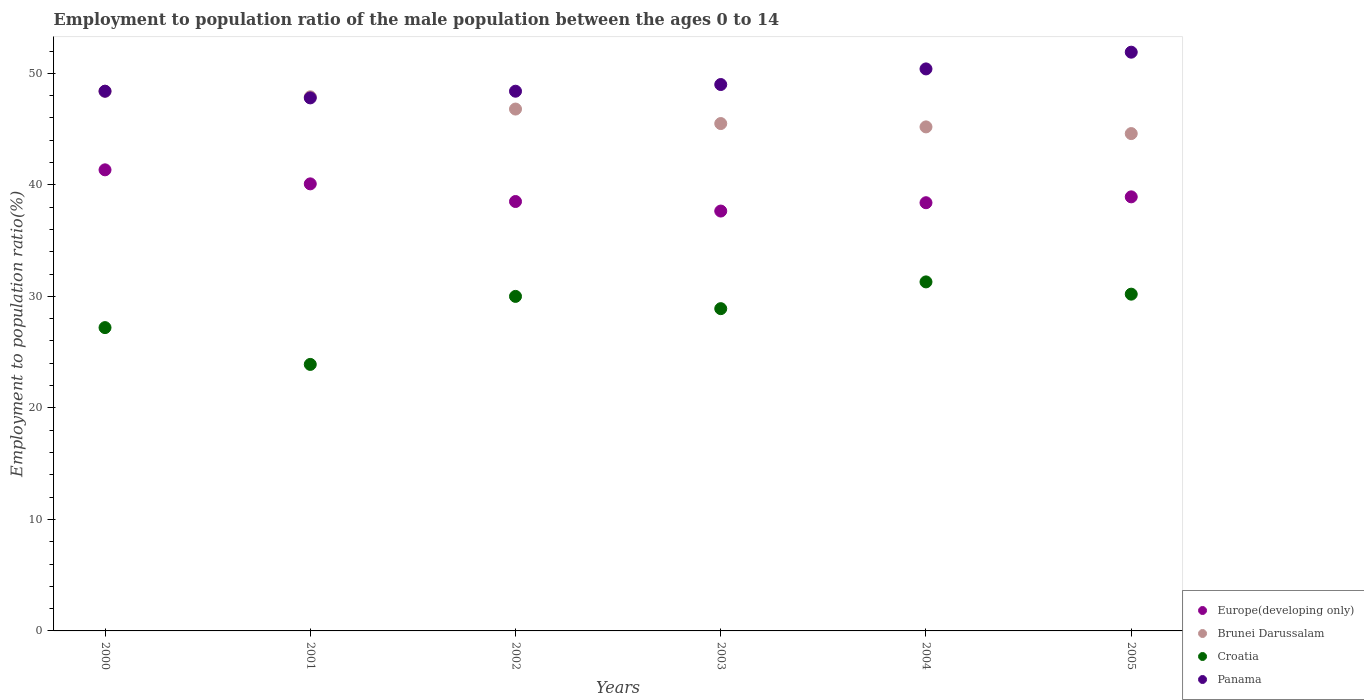How many different coloured dotlines are there?
Your response must be concise. 4. What is the employment to population ratio in Croatia in 2001?
Make the answer very short. 23.9. Across all years, what is the maximum employment to population ratio in Brunei Darussalam?
Make the answer very short. 48.4. Across all years, what is the minimum employment to population ratio in Croatia?
Offer a very short reply. 23.9. In which year was the employment to population ratio in Croatia minimum?
Offer a terse response. 2001. What is the total employment to population ratio in Brunei Darussalam in the graph?
Your response must be concise. 278.4. What is the difference between the employment to population ratio in Panama in 2000 and that in 2003?
Make the answer very short. -0.6. What is the difference between the employment to population ratio in Panama in 2001 and the employment to population ratio in Europe(developing only) in 2000?
Your response must be concise. 6.45. What is the average employment to population ratio in Brunei Darussalam per year?
Your answer should be very brief. 46.4. In the year 2002, what is the difference between the employment to population ratio in Panama and employment to population ratio in Croatia?
Your answer should be very brief. 18.4. In how many years, is the employment to population ratio in Brunei Darussalam greater than 12 %?
Give a very brief answer. 6. What is the ratio of the employment to population ratio in Brunei Darussalam in 2000 to that in 2004?
Provide a short and direct response. 1.07. Is the employment to population ratio in Europe(developing only) in 2002 less than that in 2004?
Your response must be concise. No. Is the difference between the employment to population ratio in Panama in 2001 and 2003 greater than the difference between the employment to population ratio in Croatia in 2001 and 2003?
Ensure brevity in your answer.  Yes. What is the difference between the highest and the lowest employment to population ratio in Panama?
Ensure brevity in your answer.  4.1. In how many years, is the employment to population ratio in Brunei Darussalam greater than the average employment to population ratio in Brunei Darussalam taken over all years?
Your answer should be very brief. 3. Is it the case that in every year, the sum of the employment to population ratio in Europe(developing only) and employment to population ratio in Croatia  is greater than the sum of employment to population ratio in Brunei Darussalam and employment to population ratio in Panama?
Your answer should be very brief. Yes. Is it the case that in every year, the sum of the employment to population ratio in Panama and employment to population ratio in Europe(developing only)  is greater than the employment to population ratio in Brunei Darussalam?
Give a very brief answer. Yes. Does the employment to population ratio in Panama monotonically increase over the years?
Give a very brief answer. No. Is the employment to population ratio in Brunei Darussalam strictly greater than the employment to population ratio in Croatia over the years?
Your answer should be compact. Yes. How many dotlines are there?
Your answer should be very brief. 4. How many years are there in the graph?
Provide a short and direct response. 6. Are the values on the major ticks of Y-axis written in scientific E-notation?
Provide a succinct answer. No. Does the graph contain grids?
Keep it short and to the point. No. How many legend labels are there?
Ensure brevity in your answer.  4. What is the title of the graph?
Offer a terse response. Employment to population ratio of the male population between the ages 0 to 14. Does "Bahrain" appear as one of the legend labels in the graph?
Keep it short and to the point. No. What is the label or title of the Y-axis?
Provide a short and direct response. Employment to population ratio(%). What is the Employment to population ratio(%) of Europe(developing only) in 2000?
Offer a terse response. 41.35. What is the Employment to population ratio(%) in Brunei Darussalam in 2000?
Your answer should be very brief. 48.4. What is the Employment to population ratio(%) in Croatia in 2000?
Offer a terse response. 27.2. What is the Employment to population ratio(%) in Panama in 2000?
Offer a terse response. 48.4. What is the Employment to population ratio(%) in Europe(developing only) in 2001?
Offer a very short reply. 40.09. What is the Employment to population ratio(%) of Brunei Darussalam in 2001?
Provide a short and direct response. 47.9. What is the Employment to population ratio(%) in Croatia in 2001?
Offer a very short reply. 23.9. What is the Employment to population ratio(%) in Panama in 2001?
Ensure brevity in your answer.  47.8. What is the Employment to population ratio(%) of Europe(developing only) in 2002?
Provide a short and direct response. 38.51. What is the Employment to population ratio(%) in Brunei Darussalam in 2002?
Provide a short and direct response. 46.8. What is the Employment to population ratio(%) of Croatia in 2002?
Your response must be concise. 30. What is the Employment to population ratio(%) of Panama in 2002?
Give a very brief answer. 48.4. What is the Employment to population ratio(%) in Europe(developing only) in 2003?
Offer a terse response. 37.65. What is the Employment to population ratio(%) in Brunei Darussalam in 2003?
Provide a short and direct response. 45.5. What is the Employment to population ratio(%) of Croatia in 2003?
Give a very brief answer. 28.9. What is the Employment to population ratio(%) of Panama in 2003?
Give a very brief answer. 49. What is the Employment to population ratio(%) of Europe(developing only) in 2004?
Your response must be concise. 38.4. What is the Employment to population ratio(%) of Brunei Darussalam in 2004?
Your response must be concise. 45.2. What is the Employment to population ratio(%) of Croatia in 2004?
Give a very brief answer. 31.3. What is the Employment to population ratio(%) in Panama in 2004?
Your response must be concise. 50.4. What is the Employment to population ratio(%) of Europe(developing only) in 2005?
Your answer should be compact. 38.93. What is the Employment to population ratio(%) of Brunei Darussalam in 2005?
Offer a very short reply. 44.6. What is the Employment to population ratio(%) of Croatia in 2005?
Provide a short and direct response. 30.2. What is the Employment to population ratio(%) of Panama in 2005?
Your answer should be very brief. 51.9. Across all years, what is the maximum Employment to population ratio(%) in Europe(developing only)?
Your response must be concise. 41.35. Across all years, what is the maximum Employment to population ratio(%) in Brunei Darussalam?
Provide a short and direct response. 48.4. Across all years, what is the maximum Employment to population ratio(%) of Croatia?
Your response must be concise. 31.3. Across all years, what is the maximum Employment to population ratio(%) of Panama?
Your answer should be compact. 51.9. Across all years, what is the minimum Employment to population ratio(%) of Europe(developing only)?
Make the answer very short. 37.65. Across all years, what is the minimum Employment to population ratio(%) of Brunei Darussalam?
Give a very brief answer. 44.6. Across all years, what is the minimum Employment to population ratio(%) of Croatia?
Keep it short and to the point. 23.9. Across all years, what is the minimum Employment to population ratio(%) of Panama?
Your answer should be compact. 47.8. What is the total Employment to population ratio(%) of Europe(developing only) in the graph?
Your answer should be very brief. 234.93. What is the total Employment to population ratio(%) of Brunei Darussalam in the graph?
Provide a succinct answer. 278.4. What is the total Employment to population ratio(%) of Croatia in the graph?
Offer a terse response. 171.5. What is the total Employment to population ratio(%) of Panama in the graph?
Your answer should be compact. 295.9. What is the difference between the Employment to population ratio(%) in Europe(developing only) in 2000 and that in 2001?
Offer a terse response. 1.26. What is the difference between the Employment to population ratio(%) of Brunei Darussalam in 2000 and that in 2001?
Your answer should be compact. 0.5. What is the difference between the Employment to population ratio(%) in Panama in 2000 and that in 2001?
Ensure brevity in your answer.  0.6. What is the difference between the Employment to population ratio(%) in Europe(developing only) in 2000 and that in 2002?
Give a very brief answer. 2.84. What is the difference between the Employment to population ratio(%) in Croatia in 2000 and that in 2002?
Give a very brief answer. -2.8. What is the difference between the Employment to population ratio(%) in Europe(developing only) in 2000 and that in 2003?
Give a very brief answer. 3.7. What is the difference between the Employment to population ratio(%) in Panama in 2000 and that in 2003?
Provide a short and direct response. -0.6. What is the difference between the Employment to population ratio(%) in Europe(developing only) in 2000 and that in 2004?
Your response must be concise. 2.95. What is the difference between the Employment to population ratio(%) in Brunei Darussalam in 2000 and that in 2004?
Make the answer very short. 3.2. What is the difference between the Employment to population ratio(%) in Panama in 2000 and that in 2004?
Provide a succinct answer. -2. What is the difference between the Employment to population ratio(%) in Europe(developing only) in 2000 and that in 2005?
Offer a terse response. 2.42. What is the difference between the Employment to population ratio(%) of Panama in 2000 and that in 2005?
Ensure brevity in your answer.  -3.5. What is the difference between the Employment to population ratio(%) in Europe(developing only) in 2001 and that in 2002?
Your answer should be very brief. 1.58. What is the difference between the Employment to population ratio(%) in Panama in 2001 and that in 2002?
Provide a short and direct response. -0.6. What is the difference between the Employment to population ratio(%) of Europe(developing only) in 2001 and that in 2003?
Ensure brevity in your answer.  2.44. What is the difference between the Employment to population ratio(%) in Panama in 2001 and that in 2003?
Provide a short and direct response. -1.2. What is the difference between the Employment to population ratio(%) in Europe(developing only) in 2001 and that in 2004?
Your answer should be very brief. 1.69. What is the difference between the Employment to population ratio(%) of Brunei Darussalam in 2001 and that in 2004?
Offer a very short reply. 2.7. What is the difference between the Employment to population ratio(%) of Croatia in 2001 and that in 2004?
Make the answer very short. -7.4. What is the difference between the Employment to population ratio(%) of Panama in 2001 and that in 2004?
Provide a succinct answer. -2.6. What is the difference between the Employment to population ratio(%) of Europe(developing only) in 2001 and that in 2005?
Offer a terse response. 1.16. What is the difference between the Employment to population ratio(%) of Europe(developing only) in 2002 and that in 2003?
Offer a very short reply. 0.86. What is the difference between the Employment to population ratio(%) of Panama in 2002 and that in 2003?
Ensure brevity in your answer.  -0.6. What is the difference between the Employment to population ratio(%) of Europe(developing only) in 2002 and that in 2004?
Offer a very short reply. 0.11. What is the difference between the Employment to population ratio(%) of Brunei Darussalam in 2002 and that in 2004?
Ensure brevity in your answer.  1.6. What is the difference between the Employment to population ratio(%) of Panama in 2002 and that in 2004?
Give a very brief answer. -2. What is the difference between the Employment to population ratio(%) in Europe(developing only) in 2002 and that in 2005?
Your answer should be compact. -0.42. What is the difference between the Employment to population ratio(%) in Brunei Darussalam in 2002 and that in 2005?
Offer a very short reply. 2.2. What is the difference between the Employment to population ratio(%) in Europe(developing only) in 2003 and that in 2004?
Offer a very short reply. -0.75. What is the difference between the Employment to population ratio(%) of Croatia in 2003 and that in 2004?
Give a very brief answer. -2.4. What is the difference between the Employment to population ratio(%) of Panama in 2003 and that in 2004?
Your response must be concise. -1.4. What is the difference between the Employment to population ratio(%) in Europe(developing only) in 2003 and that in 2005?
Your answer should be compact. -1.27. What is the difference between the Employment to population ratio(%) of Brunei Darussalam in 2003 and that in 2005?
Offer a very short reply. 0.9. What is the difference between the Employment to population ratio(%) in Europe(developing only) in 2004 and that in 2005?
Offer a terse response. -0.53. What is the difference between the Employment to population ratio(%) of Croatia in 2004 and that in 2005?
Your response must be concise. 1.1. What is the difference between the Employment to population ratio(%) in Europe(developing only) in 2000 and the Employment to population ratio(%) in Brunei Darussalam in 2001?
Make the answer very short. -6.55. What is the difference between the Employment to population ratio(%) in Europe(developing only) in 2000 and the Employment to population ratio(%) in Croatia in 2001?
Offer a very short reply. 17.45. What is the difference between the Employment to population ratio(%) in Europe(developing only) in 2000 and the Employment to population ratio(%) in Panama in 2001?
Offer a terse response. -6.45. What is the difference between the Employment to population ratio(%) in Croatia in 2000 and the Employment to population ratio(%) in Panama in 2001?
Offer a very short reply. -20.6. What is the difference between the Employment to population ratio(%) in Europe(developing only) in 2000 and the Employment to population ratio(%) in Brunei Darussalam in 2002?
Make the answer very short. -5.45. What is the difference between the Employment to population ratio(%) in Europe(developing only) in 2000 and the Employment to population ratio(%) in Croatia in 2002?
Keep it short and to the point. 11.35. What is the difference between the Employment to population ratio(%) in Europe(developing only) in 2000 and the Employment to population ratio(%) in Panama in 2002?
Your response must be concise. -7.05. What is the difference between the Employment to population ratio(%) of Croatia in 2000 and the Employment to population ratio(%) of Panama in 2002?
Provide a succinct answer. -21.2. What is the difference between the Employment to population ratio(%) of Europe(developing only) in 2000 and the Employment to population ratio(%) of Brunei Darussalam in 2003?
Provide a succinct answer. -4.15. What is the difference between the Employment to population ratio(%) of Europe(developing only) in 2000 and the Employment to population ratio(%) of Croatia in 2003?
Offer a very short reply. 12.45. What is the difference between the Employment to population ratio(%) in Europe(developing only) in 2000 and the Employment to population ratio(%) in Panama in 2003?
Provide a succinct answer. -7.65. What is the difference between the Employment to population ratio(%) in Brunei Darussalam in 2000 and the Employment to population ratio(%) in Panama in 2003?
Provide a succinct answer. -0.6. What is the difference between the Employment to population ratio(%) of Croatia in 2000 and the Employment to population ratio(%) of Panama in 2003?
Offer a very short reply. -21.8. What is the difference between the Employment to population ratio(%) in Europe(developing only) in 2000 and the Employment to population ratio(%) in Brunei Darussalam in 2004?
Provide a succinct answer. -3.85. What is the difference between the Employment to population ratio(%) of Europe(developing only) in 2000 and the Employment to population ratio(%) of Croatia in 2004?
Ensure brevity in your answer.  10.05. What is the difference between the Employment to population ratio(%) in Europe(developing only) in 2000 and the Employment to population ratio(%) in Panama in 2004?
Offer a terse response. -9.05. What is the difference between the Employment to population ratio(%) of Croatia in 2000 and the Employment to population ratio(%) of Panama in 2004?
Your answer should be compact. -23.2. What is the difference between the Employment to population ratio(%) in Europe(developing only) in 2000 and the Employment to population ratio(%) in Brunei Darussalam in 2005?
Offer a terse response. -3.25. What is the difference between the Employment to population ratio(%) of Europe(developing only) in 2000 and the Employment to population ratio(%) of Croatia in 2005?
Keep it short and to the point. 11.15. What is the difference between the Employment to population ratio(%) of Europe(developing only) in 2000 and the Employment to population ratio(%) of Panama in 2005?
Offer a very short reply. -10.55. What is the difference between the Employment to population ratio(%) in Brunei Darussalam in 2000 and the Employment to population ratio(%) in Croatia in 2005?
Ensure brevity in your answer.  18.2. What is the difference between the Employment to population ratio(%) in Brunei Darussalam in 2000 and the Employment to population ratio(%) in Panama in 2005?
Your answer should be compact. -3.5. What is the difference between the Employment to population ratio(%) of Croatia in 2000 and the Employment to population ratio(%) of Panama in 2005?
Your answer should be compact. -24.7. What is the difference between the Employment to population ratio(%) of Europe(developing only) in 2001 and the Employment to population ratio(%) of Brunei Darussalam in 2002?
Offer a very short reply. -6.71. What is the difference between the Employment to population ratio(%) of Europe(developing only) in 2001 and the Employment to population ratio(%) of Croatia in 2002?
Your answer should be compact. 10.09. What is the difference between the Employment to population ratio(%) in Europe(developing only) in 2001 and the Employment to population ratio(%) in Panama in 2002?
Offer a very short reply. -8.31. What is the difference between the Employment to population ratio(%) in Brunei Darussalam in 2001 and the Employment to population ratio(%) in Croatia in 2002?
Provide a short and direct response. 17.9. What is the difference between the Employment to population ratio(%) of Croatia in 2001 and the Employment to population ratio(%) of Panama in 2002?
Make the answer very short. -24.5. What is the difference between the Employment to population ratio(%) of Europe(developing only) in 2001 and the Employment to population ratio(%) of Brunei Darussalam in 2003?
Offer a very short reply. -5.41. What is the difference between the Employment to population ratio(%) of Europe(developing only) in 2001 and the Employment to population ratio(%) of Croatia in 2003?
Ensure brevity in your answer.  11.19. What is the difference between the Employment to population ratio(%) in Europe(developing only) in 2001 and the Employment to population ratio(%) in Panama in 2003?
Provide a short and direct response. -8.91. What is the difference between the Employment to population ratio(%) in Croatia in 2001 and the Employment to population ratio(%) in Panama in 2003?
Provide a short and direct response. -25.1. What is the difference between the Employment to population ratio(%) of Europe(developing only) in 2001 and the Employment to population ratio(%) of Brunei Darussalam in 2004?
Make the answer very short. -5.11. What is the difference between the Employment to population ratio(%) in Europe(developing only) in 2001 and the Employment to population ratio(%) in Croatia in 2004?
Offer a terse response. 8.79. What is the difference between the Employment to population ratio(%) of Europe(developing only) in 2001 and the Employment to population ratio(%) of Panama in 2004?
Make the answer very short. -10.31. What is the difference between the Employment to population ratio(%) of Brunei Darussalam in 2001 and the Employment to population ratio(%) of Croatia in 2004?
Keep it short and to the point. 16.6. What is the difference between the Employment to population ratio(%) in Croatia in 2001 and the Employment to population ratio(%) in Panama in 2004?
Offer a very short reply. -26.5. What is the difference between the Employment to population ratio(%) of Europe(developing only) in 2001 and the Employment to population ratio(%) of Brunei Darussalam in 2005?
Offer a very short reply. -4.51. What is the difference between the Employment to population ratio(%) in Europe(developing only) in 2001 and the Employment to population ratio(%) in Croatia in 2005?
Give a very brief answer. 9.89. What is the difference between the Employment to population ratio(%) in Europe(developing only) in 2001 and the Employment to population ratio(%) in Panama in 2005?
Make the answer very short. -11.81. What is the difference between the Employment to population ratio(%) of Brunei Darussalam in 2001 and the Employment to population ratio(%) of Croatia in 2005?
Keep it short and to the point. 17.7. What is the difference between the Employment to population ratio(%) of Europe(developing only) in 2002 and the Employment to population ratio(%) of Brunei Darussalam in 2003?
Keep it short and to the point. -6.99. What is the difference between the Employment to population ratio(%) of Europe(developing only) in 2002 and the Employment to population ratio(%) of Croatia in 2003?
Provide a short and direct response. 9.61. What is the difference between the Employment to population ratio(%) in Europe(developing only) in 2002 and the Employment to population ratio(%) in Panama in 2003?
Make the answer very short. -10.49. What is the difference between the Employment to population ratio(%) of Brunei Darussalam in 2002 and the Employment to population ratio(%) of Panama in 2003?
Your response must be concise. -2.2. What is the difference between the Employment to population ratio(%) in Croatia in 2002 and the Employment to population ratio(%) in Panama in 2003?
Offer a terse response. -19. What is the difference between the Employment to population ratio(%) in Europe(developing only) in 2002 and the Employment to population ratio(%) in Brunei Darussalam in 2004?
Give a very brief answer. -6.69. What is the difference between the Employment to population ratio(%) of Europe(developing only) in 2002 and the Employment to population ratio(%) of Croatia in 2004?
Provide a short and direct response. 7.21. What is the difference between the Employment to population ratio(%) of Europe(developing only) in 2002 and the Employment to population ratio(%) of Panama in 2004?
Provide a succinct answer. -11.89. What is the difference between the Employment to population ratio(%) in Brunei Darussalam in 2002 and the Employment to population ratio(%) in Croatia in 2004?
Your answer should be very brief. 15.5. What is the difference between the Employment to population ratio(%) of Brunei Darussalam in 2002 and the Employment to population ratio(%) of Panama in 2004?
Provide a succinct answer. -3.6. What is the difference between the Employment to population ratio(%) in Croatia in 2002 and the Employment to population ratio(%) in Panama in 2004?
Provide a short and direct response. -20.4. What is the difference between the Employment to population ratio(%) of Europe(developing only) in 2002 and the Employment to population ratio(%) of Brunei Darussalam in 2005?
Provide a short and direct response. -6.09. What is the difference between the Employment to population ratio(%) in Europe(developing only) in 2002 and the Employment to population ratio(%) in Croatia in 2005?
Provide a short and direct response. 8.31. What is the difference between the Employment to population ratio(%) of Europe(developing only) in 2002 and the Employment to population ratio(%) of Panama in 2005?
Give a very brief answer. -13.39. What is the difference between the Employment to population ratio(%) in Brunei Darussalam in 2002 and the Employment to population ratio(%) in Panama in 2005?
Ensure brevity in your answer.  -5.1. What is the difference between the Employment to population ratio(%) in Croatia in 2002 and the Employment to population ratio(%) in Panama in 2005?
Offer a terse response. -21.9. What is the difference between the Employment to population ratio(%) in Europe(developing only) in 2003 and the Employment to population ratio(%) in Brunei Darussalam in 2004?
Your answer should be very brief. -7.55. What is the difference between the Employment to population ratio(%) in Europe(developing only) in 2003 and the Employment to population ratio(%) in Croatia in 2004?
Offer a terse response. 6.35. What is the difference between the Employment to population ratio(%) of Europe(developing only) in 2003 and the Employment to population ratio(%) of Panama in 2004?
Provide a succinct answer. -12.75. What is the difference between the Employment to population ratio(%) of Brunei Darussalam in 2003 and the Employment to population ratio(%) of Croatia in 2004?
Your answer should be very brief. 14.2. What is the difference between the Employment to population ratio(%) of Brunei Darussalam in 2003 and the Employment to population ratio(%) of Panama in 2004?
Offer a terse response. -4.9. What is the difference between the Employment to population ratio(%) in Croatia in 2003 and the Employment to population ratio(%) in Panama in 2004?
Your response must be concise. -21.5. What is the difference between the Employment to population ratio(%) of Europe(developing only) in 2003 and the Employment to population ratio(%) of Brunei Darussalam in 2005?
Your answer should be compact. -6.95. What is the difference between the Employment to population ratio(%) of Europe(developing only) in 2003 and the Employment to population ratio(%) of Croatia in 2005?
Your response must be concise. 7.45. What is the difference between the Employment to population ratio(%) of Europe(developing only) in 2003 and the Employment to population ratio(%) of Panama in 2005?
Give a very brief answer. -14.25. What is the difference between the Employment to population ratio(%) in Brunei Darussalam in 2003 and the Employment to population ratio(%) in Croatia in 2005?
Your answer should be compact. 15.3. What is the difference between the Employment to population ratio(%) of Brunei Darussalam in 2003 and the Employment to population ratio(%) of Panama in 2005?
Provide a succinct answer. -6.4. What is the difference between the Employment to population ratio(%) of Europe(developing only) in 2004 and the Employment to population ratio(%) of Brunei Darussalam in 2005?
Offer a very short reply. -6.2. What is the difference between the Employment to population ratio(%) in Europe(developing only) in 2004 and the Employment to population ratio(%) in Croatia in 2005?
Make the answer very short. 8.2. What is the difference between the Employment to population ratio(%) of Europe(developing only) in 2004 and the Employment to population ratio(%) of Panama in 2005?
Your response must be concise. -13.5. What is the difference between the Employment to population ratio(%) in Croatia in 2004 and the Employment to population ratio(%) in Panama in 2005?
Ensure brevity in your answer.  -20.6. What is the average Employment to population ratio(%) of Europe(developing only) per year?
Your answer should be compact. 39.15. What is the average Employment to population ratio(%) of Brunei Darussalam per year?
Your response must be concise. 46.4. What is the average Employment to population ratio(%) of Croatia per year?
Ensure brevity in your answer.  28.58. What is the average Employment to population ratio(%) in Panama per year?
Provide a short and direct response. 49.32. In the year 2000, what is the difference between the Employment to population ratio(%) of Europe(developing only) and Employment to population ratio(%) of Brunei Darussalam?
Provide a succinct answer. -7.05. In the year 2000, what is the difference between the Employment to population ratio(%) in Europe(developing only) and Employment to population ratio(%) in Croatia?
Keep it short and to the point. 14.15. In the year 2000, what is the difference between the Employment to population ratio(%) in Europe(developing only) and Employment to population ratio(%) in Panama?
Your response must be concise. -7.05. In the year 2000, what is the difference between the Employment to population ratio(%) of Brunei Darussalam and Employment to population ratio(%) of Croatia?
Your answer should be compact. 21.2. In the year 2000, what is the difference between the Employment to population ratio(%) of Brunei Darussalam and Employment to population ratio(%) of Panama?
Your answer should be compact. 0. In the year 2000, what is the difference between the Employment to population ratio(%) in Croatia and Employment to population ratio(%) in Panama?
Offer a very short reply. -21.2. In the year 2001, what is the difference between the Employment to population ratio(%) in Europe(developing only) and Employment to population ratio(%) in Brunei Darussalam?
Provide a short and direct response. -7.81. In the year 2001, what is the difference between the Employment to population ratio(%) of Europe(developing only) and Employment to population ratio(%) of Croatia?
Offer a terse response. 16.19. In the year 2001, what is the difference between the Employment to population ratio(%) in Europe(developing only) and Employment to population ratio(%) in Panama?
Your response must be concise. -7.71. In the year 2001, what is the difference between the Employment to population ratio(%) of Croatia and Employment to population ratio(%) of Panama?
Your answer should be compact. -23.9. In the year 2002, what is the difference between the Employment to population ratio(%) in Europe(developing only) and Employment to population ratio(%) in Brunei Darussalam?
Your answer should be very brief. -8.29. In the year 2002, what is the difference between the Employment to population ratio(%) in Europe(developing only) and Employment to population ratio(%) in Croatia?
Provide a short and direct response. 8.51. In the year 2002, what is the difference between the Employment to population ratio(%) in Europe(developing only) and Employment to population ratio(%) in Panama?
Your response must be concise. -9.89. In the year 2002, what is the difference between the Employment to population ratio(%) of Brunei Darussalam and Employment to population ratio(%) of Panama?
Your answer should be very brief. -1.6. In the year 2002, what is the difference between the Employment to population ratio(%) in Croatia and Employment to population ratio(%) in Panama?
Give a very brief answer. -18.4. In the year 2003, what is the difference between the Employment to population ratio(%) in Europe(developing only) and Employment to population ratio(%) in Brunei Darussalam?
Your response must be concise. -7.85. In the year 2003, what is the difference between the Employment to population ratio(%) in Europe(developing only) and Employment to population ratio(%) in Croatia?
Your answer should be very brief. 8.75. In the year 2003, what is the difference between the Employment to population ratio(%) in Europe(developing only) and Employment to population ratio(%) in Panama?
Keep it short and to the point. -11.35. In the year 2003, what is the difference between the Employment to population ratio(%) of Brunei Darussalam and Employment to population ratio(%) of Panama?
Provide a succinct answer. -3.5. In the year 2003, what is the difference between the Employment to population ratio(%) in Croatia and Employment to population ratio(%) in Panama?
Offer a terse response. -20.1. In the year 2004, what is the difference between the Employment to population ratio(%) in Europe(developing only) and Employment to population ratio(%) in Brunei Darussalam?
Your response must be concise. -6.8. In the year 2004, what is the difference between the Employment to population ratio(%) of Europe(developing only) and Employment to population ratio(%) of Croatia?
Offer a terse response. 7.1. In the year 2004, what is the difference between the Employment to population ratio(%) in Europe(developing only) and Employment to population ratio(%) in Panama?
Provide a short and direct response. -12. In the year 2004, what is the difference between the Employment to population ratio(%) of Brunei Darussalam and Employment to population ratio(%) of Croatia?
Offer a terse response. 13.9. In the year 2004, what is the difference between the Employment to population ratio(%) in Croatia and Employment to population ratio(%) in Panama?
Keep it short and to the point. -19.1. In the year 2005, what is the difference between the Employment to population ratio(%) in Europe(developing only) and Employment to population ratio(%) in Brunei Darussalam?
Offer a terse response. -5.67. In the year 2005, what is the difference between the Employment to population ratio(%) in Europe(developing only) and Employment to population ratio(%) in Croatia?
Provide a short and direct response. 8.73. In the year 2005, what is the difference between the Employment to population ratio(%) in Europe(developing only) and Employment to population ratio(%) in Panama?
Your response must be concise. -12.97. In the year 2005, what is the difference between the Employment to population ratio(%) of Brunei Darussalam and Employment to population ratio(%) of Croatia?
Your response must be concise. 14.4. In the year 2005, what is the difference between the Employment to population ratio(%) in Croatia and Employment to population ratio(%) in Panama?
Your response must be concise. -21.7. What is the ratio of the Employment to population ratio(%) in Europe(developing only) in 2000 to that in 2001?
Ensure brevity in your answer.  1.03. What is the ratio of the Employment to population ratio(%) in Brunei Darussalam in 2000 to that in 2001?
Your answer should be compact. 1.01. What is the ratio of the Employment to population ratio(%) of Croatia in 2000 to that in 2001?
Your response must be concise. 1.14. What is the ratio of the Employment to population ratio(%) in Panama in 2000 to that in 2001?
Give a very brief answer. 1.01. What is the ratio of the Employment to population ratio(%) in Europe(developing only) in 2000 to that in 2002?
Keep it short and to the point. 1.07. What is the ratio of the Employment to population ratio(%) in Brunei Darussalam in 2000 to that in 2002?
Keep it short and to the point. 1.03. What is the ratio of the Employment to population ratio(%) in Croatia in 2000 to that in 2002?
Your answer should be very brief. 0.91. What is the ratio of the Employment to population ratio(%) in Europe(developing only) in 2000 to that in 2003?
Offer a terse response. 1.1. What is the ratio of the Employment to population ratio(%) in Brunei Darussalam in 2000 to that in 2003?
Your response must be concise. 1.06. What is the ratio of the Employment to population ratio(%) of Panama in 2000 to that in 2003?
Your answer should be very brief. 0.99. What is the ratio of the Employment to population ratio(%) in Europe(developing only) in 2000 to that in 2004?
Your response must be concise. 1.08. What is the ratio of the Employment to population ratio(%) of Brunei Darussalam in 2000 to that in 2004?
Ensure brevity in your answer.  1.07. What is the ratio of the Employment to population ratio(%) of Croatia in 2000 to that in 2004?
Provide a short and direct response. 0.87. What is the ratio of the Employment to population ratio(%) in Panama in 2000 to that in 2004?
Provide a succinct answer. 0.96. What is the ratio of the Employment to population ratio(%) of Europe(developing only) in 2000 to that in 2005?
Offer a very short reply. 1.06. What is the ratio of the Employment to population ratio(%) of Brunei Darussalam in 2000 to that in 2005?
Your response must be concise. 1.09. What is the ratio of the Employment to population ratio(%) in Croatia in 2000 to that in 2005?
Your answer should be compact. 0.9. What is the ratio of the Employment to population ratio(%) of Panama in 2000 to that in 2005?
Offer a very short reply. 0.93. What is the ratio of the Employment to population ratio(%) of Europe(developing only) in 2001 to that in 2002?
Offer a terse response. 1.04. What is the ratio of the Employment to population ratio(%) of Brunei Darussalam in 2001 to that in 2002?
Your response must be concise. 1.02. What is the ratio of the Employment to population ratio(%) of Croatia in 2001 to that in 2002?
Keep it short and to the point. 0.8. What is the ratio of the Employment to population ratio(%) of Panama in 2001 to that in 2002?
Keep it short and to the point. 0.99. What is the ratio of the Employment to population ratio(%) of Europe(developing only) in 2001 to that in 2003?
Your answer should be very brief. 1.06. What is the ratio of the Employment to population ratio(%) of Brunei Darussalam in 2001 to that in 2003?
Offer a terse response. 1.05. What is the ratio of the Employment to population ratio(%) in Croatia in 2001 to that in 2003?
Make the answer very short. 0.83. What is the ratio of the Employment to population ratio(%) of Panama in 2001 to that in 2003?
Make the answer very short. 0.98. What is the ratio of the Employment to population ratio(%) of Europe(developing only) in 2001 to that in 2004?
Offer a very short reply. 1.04. What is the ratio of the Employment to population ratio(%) in Brunei Darussalam in 2001 to that in 2004?
Your answer should be very brief. 1.06. What is the ratio of the Employment to population ratio(%) in Croatia in 2001 to that in 2004?
Provide a short and direct response. 0.76. What is the ratio of the Employment to population ratio(%) of Panama in 2001 to that in 2004?
Keep it short and to the point. 0.95. What is the ratio of the Employment to population ratio(%) in Europe(developing only) in 2001 to that in 2005?
Ensure brevity in your answer.  1.03. What is the ratio of the Employment to population ratio(%) in Brunei Darussalam in 2001 to that in 2005?
Provide a succinct answer. 1.07. What is the ratio of the Employment to population ratio(%) of Croatia in 2001 to that in 2005?
Your answer should be very brief. 0.79. What is the ratio of the Employment to population ratio(%) in Panama in 2001 to that in 2005?
Provide a short and direct response. 0.92. What is the ratio of the Employment to population ratio(%) of Europe(developing only) in 2002 to that in 2003?
Make the answer very short. 1.02. What is the ratio of the Employment to population ratio(%) in Brunei Darussalam in 2002 to that in 2003?
Give a very brief answer. 1.03. What is the ratio of the Employment to population ratio(%) of Croatia in 2002 to that in 2003?
Provide a short and direct response. 1.04. What is the ratio of the Employment to population ratio(%) in Brunei Darussalam in 2002 to that in 2004?
Provide a succinct answer. 1.04. What is the ratio of the Employment to population ratio(%) in Croatia in 2002 to that in 2004?
Make the answer very short. 0.96. What is the ratio of the Employment to population ratio(%) of Panama in 2002 to that in 2004?
Give a very brief answer. 0.96. What is the ratio of the Employment to population ratio(%) of Europe(developing only) in 2002 to that in 2005?
Provide a succinct answer. 0.99. What is the ratio of the Employment to population ratio(%) in Brunei Darussalam in 2002 to that in 2005?
Give a very brief answer. 1.05. What is the ratio of the Employment to population ratio(%) in Croatia in 2002 to that in 2005?
Ensure brevity in your answer.  0.99. What is the ratio of the Employment to population ratio(%) of Panama in 2002 to that in 2005?
Offer a very short reply. 0.93. What is the ratio of the Employment to population ratio(%) in Europe(developing only) in 2003 to that in 2004?
Provide a short and direct response. 0.98. What is the ratio of the Employment to population ratio(%) in Brunei Darussalam in 2003 to that in 2004?
Make the answer very short. 1.01. What is the ratio of the Employment to population ratio(%) of Croatia in 2003 to that in 2004?
Make the answer very short. 0.92. What is the ratio of the Employment to population ratio(%) of Panama in 2003 to that in 2004?
Your response must be concise. 0.97. What is the ratio of the Employment to population ratio(%) in Europe(developing only) in 2003 to that in 2005?
Provide a short and direct response. 0.97. What is the ratio of the Employment to population ratio(%) in Brunei Darussalam in 2003 to that in 2005?
Your answer should be very brief. 1.02. What is the ratio of the Employment to population ratio(%) of Croatia in 2003 to that in 2005?
Offer a terse response. 0.96. What is the ratio of the Employment to population ratio(%) in Panama in 2003 to that in 2005?
Keep it short and to the point. 0.94. What is the ratio of the Employment to population ratio(%) in Europe(developing only) in 2004 to that in 2005?
Your answer should be very brief. 0.99. What is the ratio of the Employment to population ratio(%) in Brunei Darussalam in 2004 to that in 2005?
Keep it short and to the point. 1.01. What is the ratio of the Employment to population ratio(%) of Croatia in 2004 to that in 2005?
Provide a short and direct response. 1.04. What is the ratio of the Employment to population ratio(%) in Panama in 2004 to that in 2005?
Your answer should be very brief. 0.97. What is the difference between the highest and the second highest Employment to population ratio(%) of Europe(developing only)?
Make the answer very short. 1.26. What is the difference between the highest and the second highest Employment to population ratio(%) of Croatia?
Ensure brevity in your answer.  1.1. What is the difference between the highest and the lowest Employment to population ratio(%) of Europe(developing only)?
Your response must be concise. 3.7. What is the difference between the highest and the lowest Employment to population ratio(%) in Brunei Darussalam?
Ensure brevity in your answer.  3.8. What is the difference between the highest and the lowest Employment to population ratio(%) of Croatia?
Your response must be concise. 7.4. What is the difference between the highest and the lowest Employment to population ratio(%) of Panama?
Your response must be concise. 4.1. 